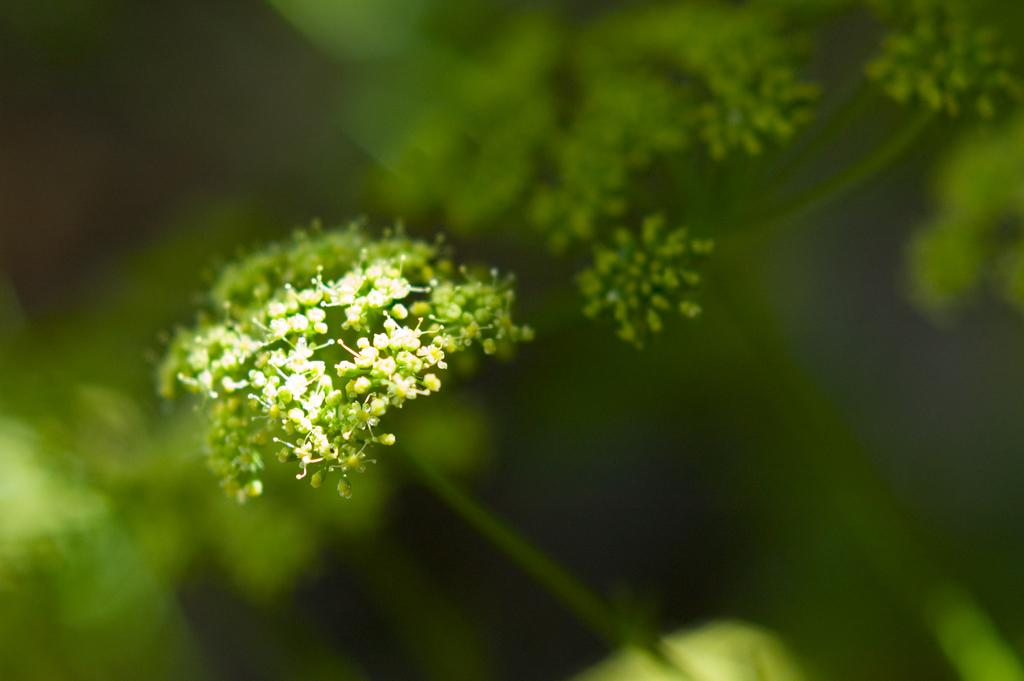What is present in the image? There are flowers in the image. Can you describe the background of the image? The background of the image is blurry. What type of organization is responsible for the flowers in the image? There is no information about an organization responsible for the flowers in the image. 